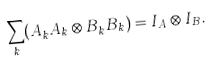Convert formula to latex. <formula><loc_0><loc_0><loc_500><loc_500>\sum _ { k } ( A _ { k } ^ { \dagger } A _ { k } \otimes B _ { k } ^ { \dagger } B _ { k } ) = I _ { A } \otimes I _ { B } .</formula> 